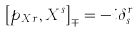Convert formula to latex. <formula><loc_0><loc_0><loc_500><loc_500>\left [ p _ { X r } , X ^ { s } \right ] _ { \mp } = - i \delta _ { s } ^ { r }</formula> 